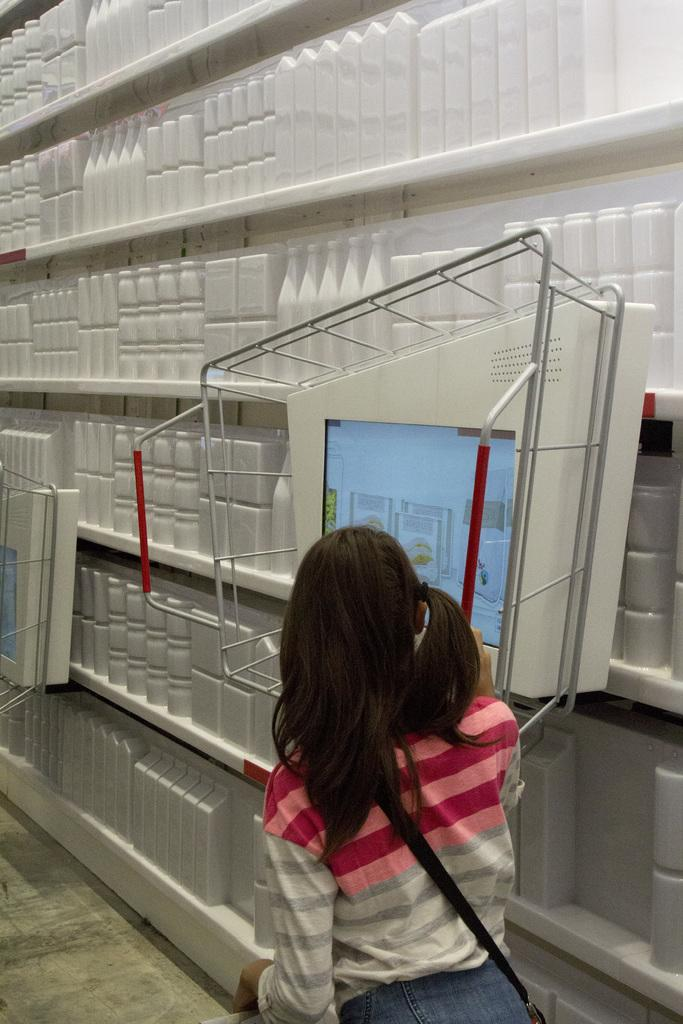What is the main subject of the image? There is a person standing in the image. What is in front of the person? There is an object that looks like a screen in front of the person. What else can be seen in the image besides the person and the screen? There is a rack with objects in the image. What is the color of the objects on the rack? The objects on the rack are white in color. Can you tell me how many trains are visible in the image? There are no trains visible in the image. What type of apparatus is being used by the person in the image? The image does not provide enough information to determine the type of apparatus being used by the person. 